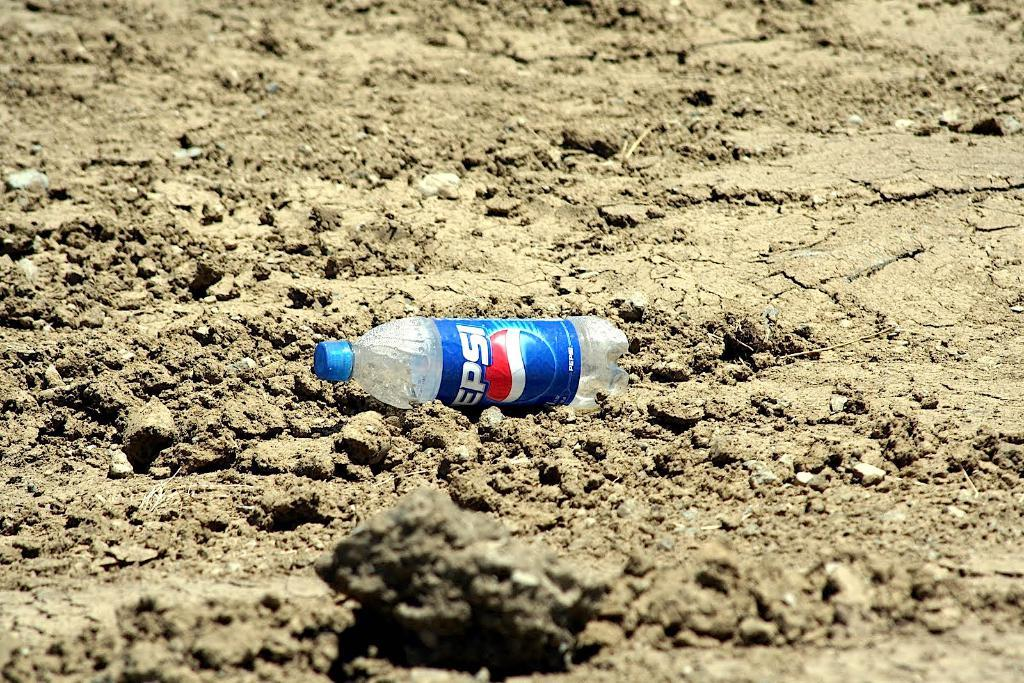<image>
Provide a brief description of the given image. An empty Pepsi bottle lays on the dirt, 